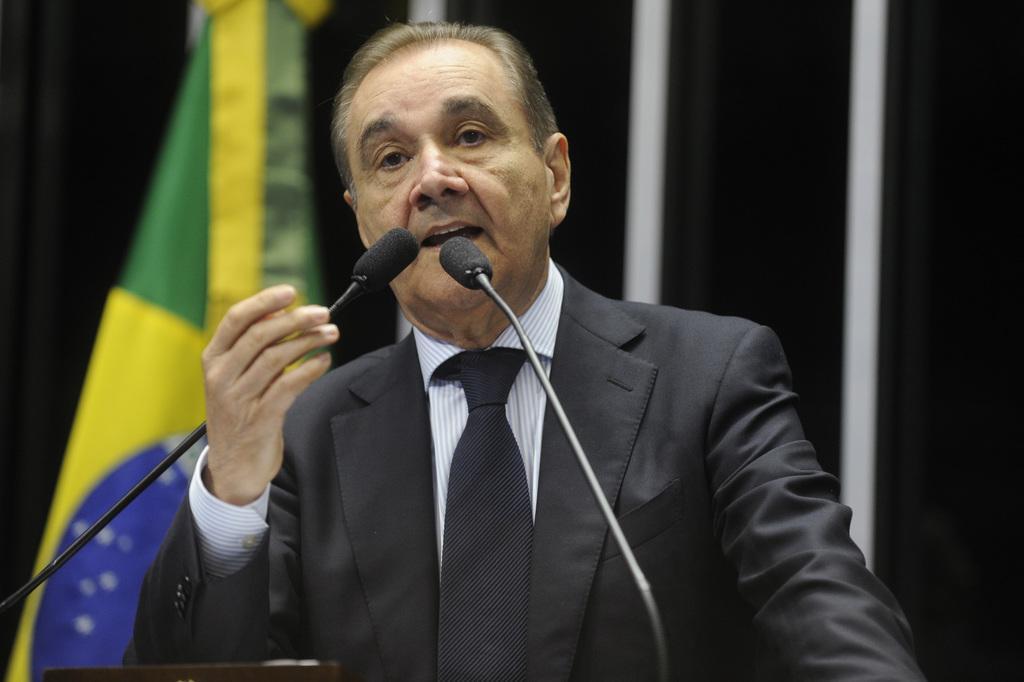How would you summarize this image in a sentence or two? In this image we can see a person standing and there are two mics in front of the person and there is a flag in the background. 